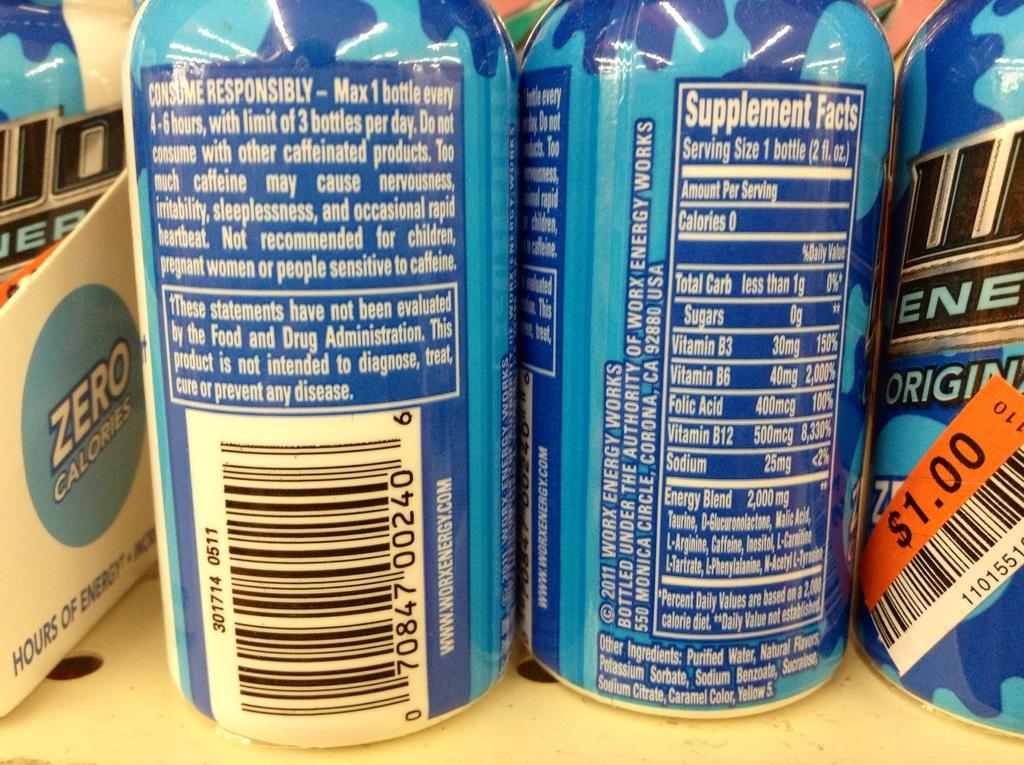<image>
Present a compact description of the photo's key features. Bottles of an energy drink displaying the directions for consumption on the back. 